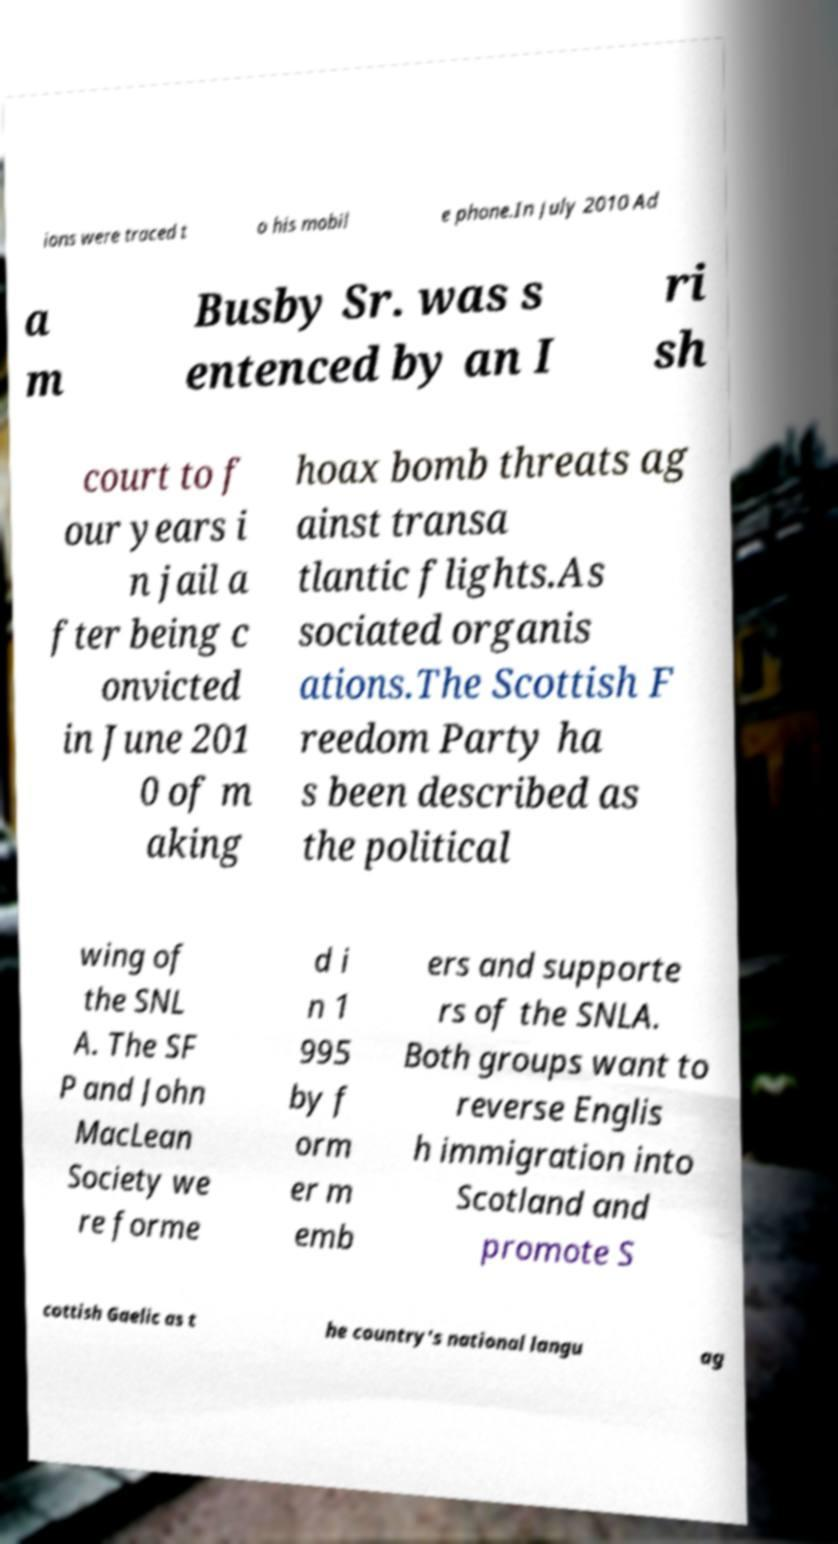For documentation purposes, I need the text within this image transcribed. Could you provide that? ions were traced t o his mobil e phone.In July 2010 Ad a m Busby Sr. was s entenced by an I ri sh court to f our years i n jail a fter being c onvicted in June 201 0 of m aking hoax bomb threats ag ainst transa tlantic flights.As sociated organis ations.The Scottish F reedom Party ha s been described as the political wing of the SNL A. The SF P and John MacLean Society we re forme d i n 1 995 by f orm er m emb ers and supporte rs of the SNLA. Both groups want to reverse Englis h immigration into Scotland and promote S cottish Gaelic as t he country's national langu ag 